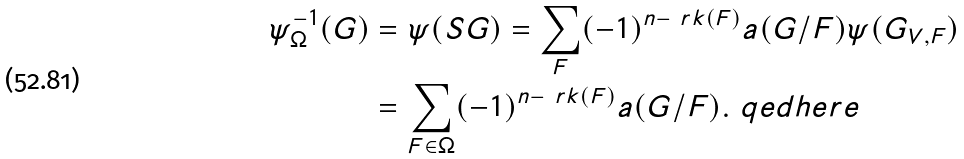Convert formula to latex. <formula><loc_0><loc_0><loc_500><loc_500>\psi _ { \Omega } ^ { - 1 } ( G ) & = \psi ( S G ) = \sum _ { F } ( - 1 ) ^ { n - \ r k ( F ) } a ( G / F ) \psi ( G _ { V , F } ) \\ & = \sum _ { F \in \Omega } ( - 1 ) ^ { n - \ r k ( F ) } a ( G / F ) . \ q e d h e r e</formula> 